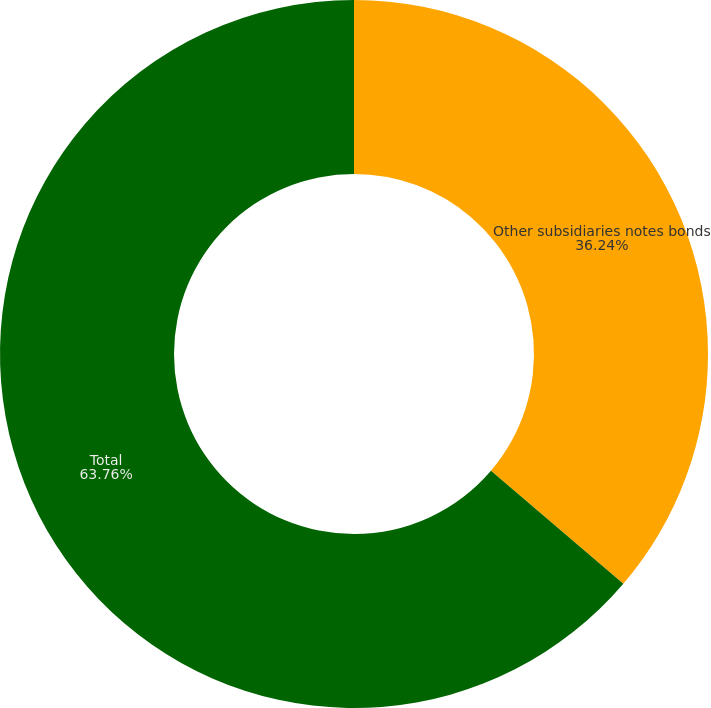<chart> <loc_0><loc_0><loc_500><loc_500><pie_chart><fcel>Other subsidiaries notes bonds<fcel>Total<nl><fcel>36.24%<fcel>63.76%<nl></chart> 